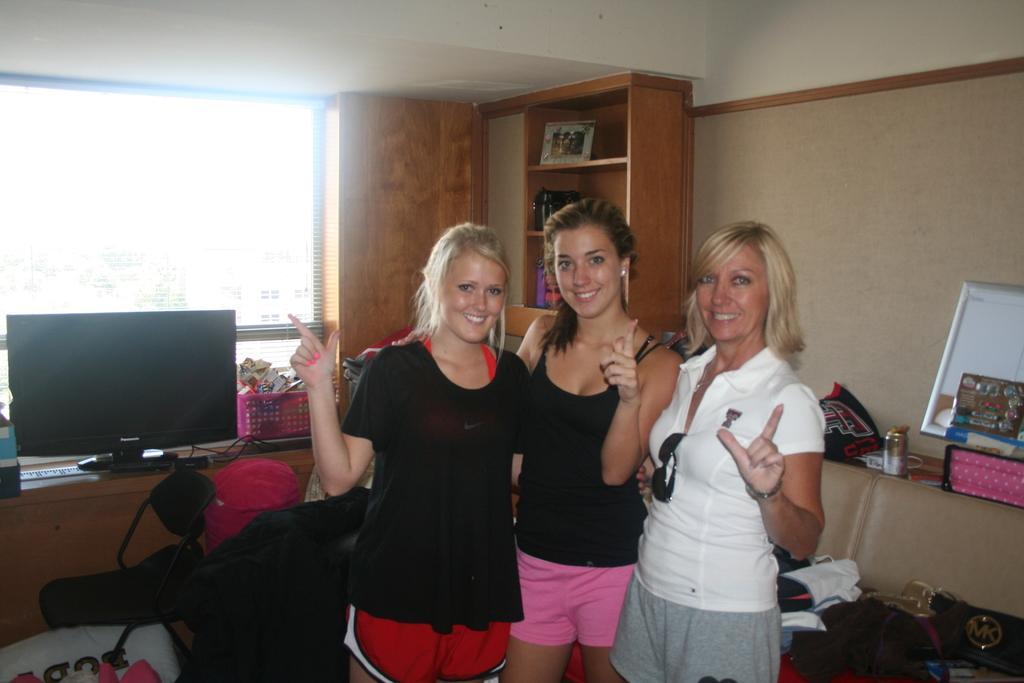Describe this image in one or two sentences. In this image there are three women standing with a smile on their face, behind them there is a chair, behind the chair on the table there is a monitor, behind the monitor there is a basket, behind the basket there is a window. 